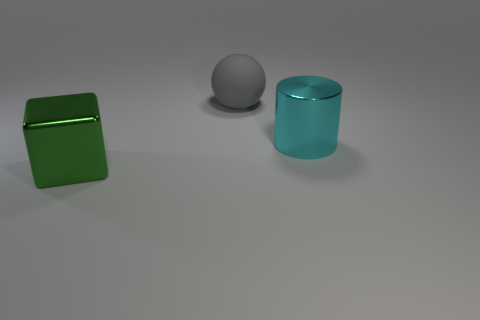Add 3 brown rubber cubes. How many objects exist? 6 Subtract all cylinders. How many objects are left? 2 Add 1 cyan metallic things. How many cyan metallic things are left? 2 Add 3 tiny rubber blocks. How many tiny rubber blocks exist? 3 Subtract 0 purple balls. How many objects are left? 3 Subtract all green shiny cubes. Subtract all small cyan matte cylinders. How many objects are left? 2 